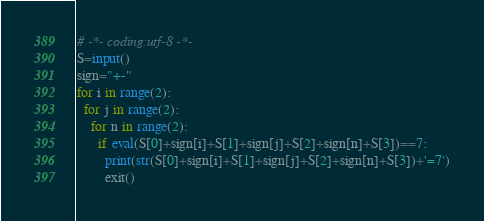Convert code to text. <code><loc_0><loc_0><loc_500><loc_500><_Python_># -*- coding:utf-8 -*-
S=input()
sign="+-"
for i in range(2):
  for j in range(2):
    for n in range(2):
      if eval(S[0]+sign[i]+S[1]+sign[j]+S[2]+sign[n]+S[3])==7:
        print(str(S[0]+sign[i]+S[1]+sign[j]+S[2]+sign[n]+S[3])+'=7')
        exit()</code> 